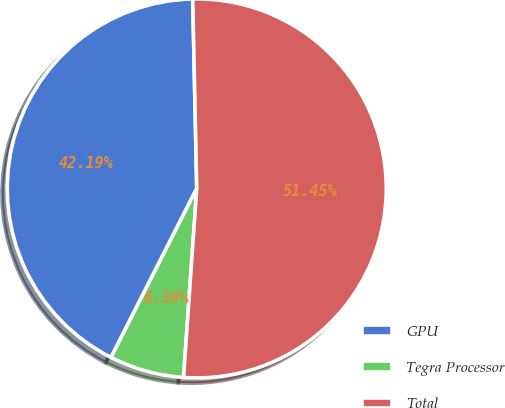Convert chart. <chart><loc_0><loc_0><loc_500><loc_500><pie_chart><fcel>GPU<fcel>Tegra Processor<fcel>Total<nl><fcel>42.19%<fcel>6.36%<fcel>51.45%<nl></chart> 